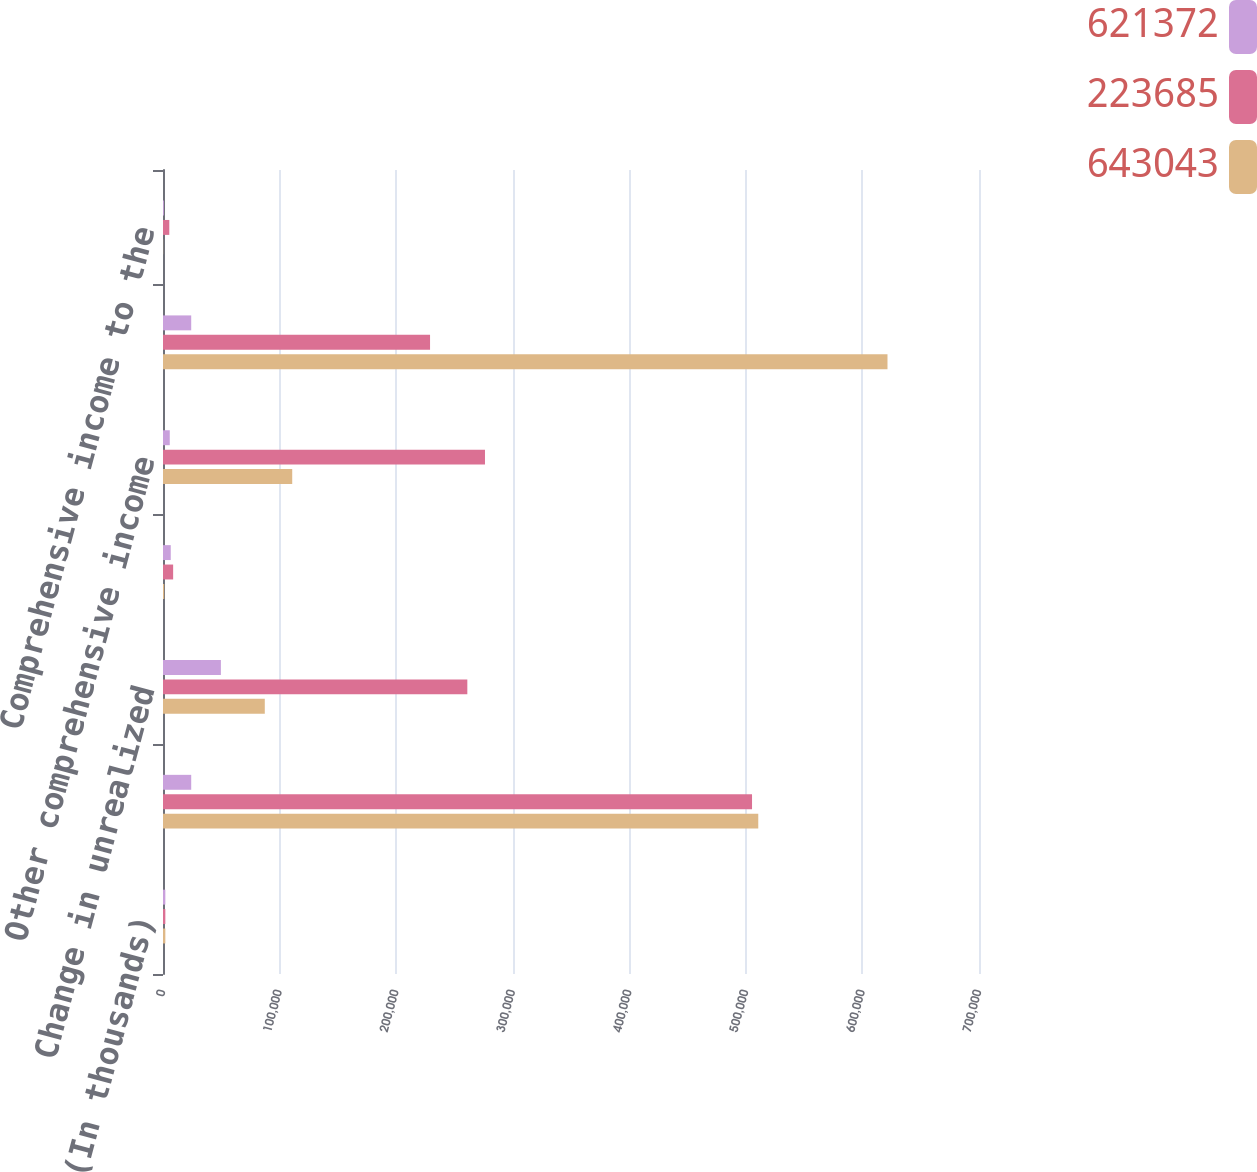Convert chart. <chart><loc_0><loc_0><loc_500><loc_500><stacked_bar_chart><ecel><fcel>(In thousands)<fcel>Net income before<fcel>Change in unrealized<fcel>Change in unrecognized pension<fcel>Other comprehensive income<fcel>Comprehensive income<fcel>Comprehensive income to the<nl><fcel>621372<fcel>2014<fcel>24205.5<fcel>49666<fcel>6651<fcel>5808<fcel>24205.5<fcel>752<nl><fcel>223685<fcel>2013<fcel>505301<fcel>261064<fcel>8700<fcel>276212<fcel>229089<fcel>5404<nl><fcel>643043<fcel>2012<fcel>510643<fcel>87316<fcel>1022<fcel>110857<fcel>621500<fcel>128<nl></chart> 